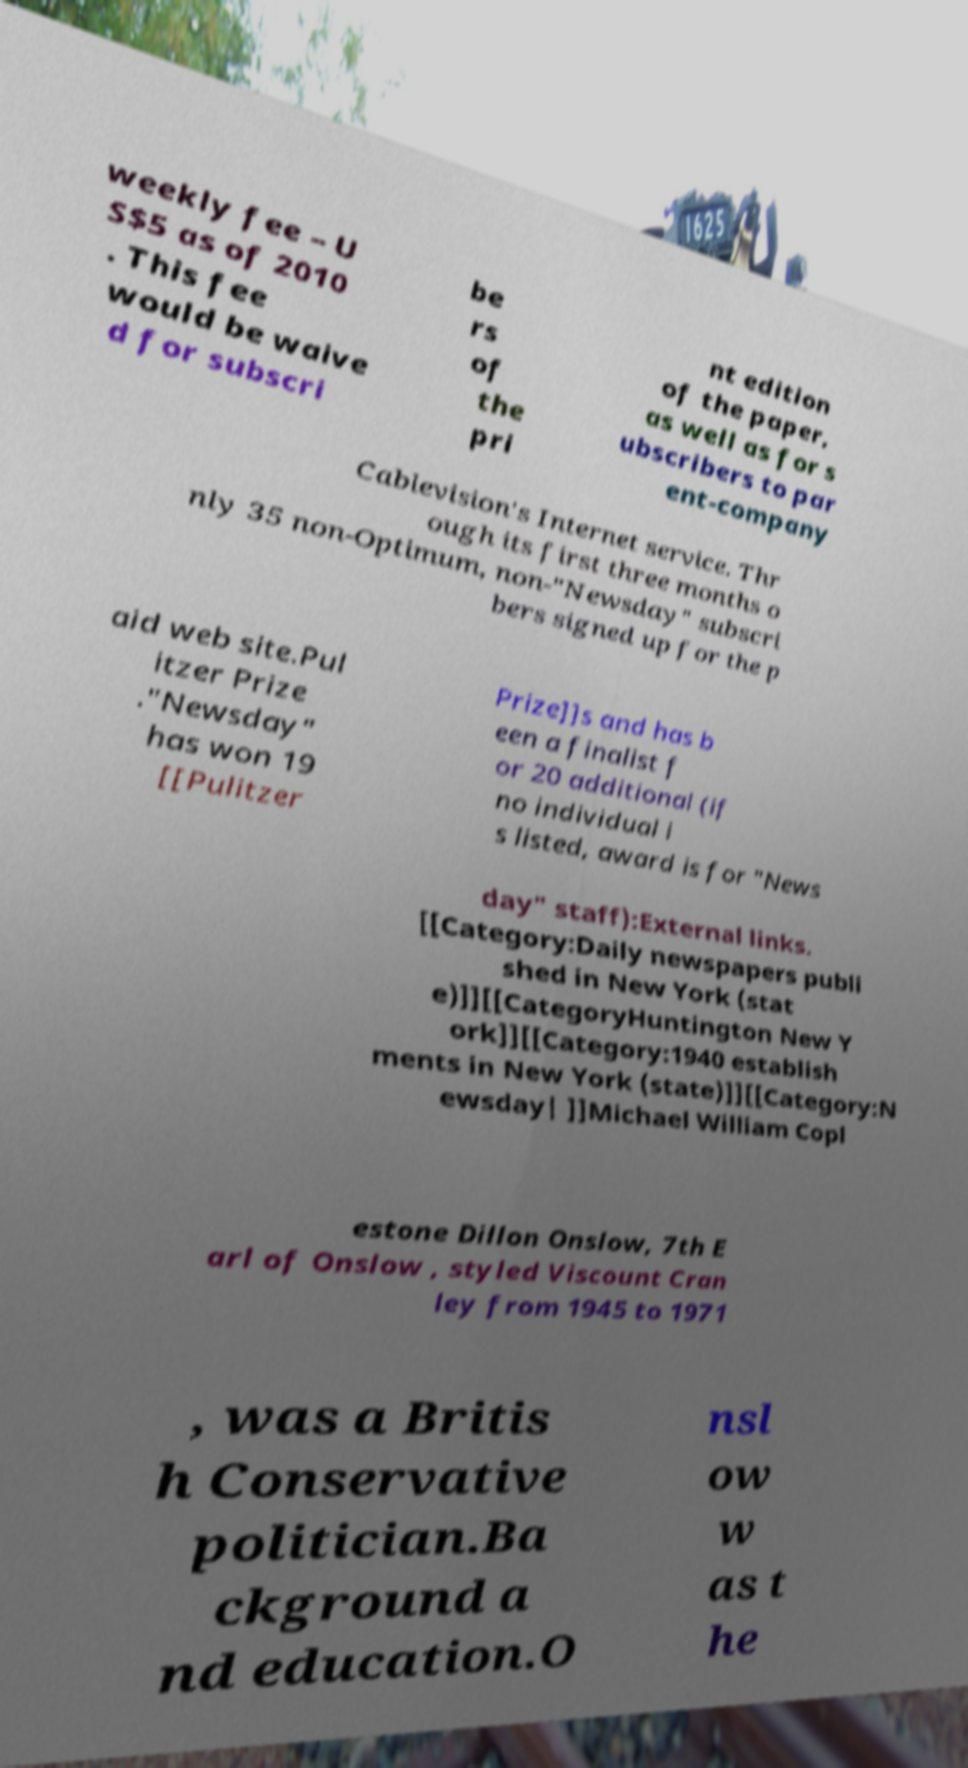What messages or text are displayed in this image? I need them in a readable, typed format. weekly fee – U S$5 as of 2010 . This fee would be waive d for subscri be rs of the pri nt edition of the paper, as well as for s ubscribers to par ent-company Cablevision's Internet service. Thr ough its first three months o nly 35 non-Optimum, non-"Newsday" subscri bers signed up for the p aid web site.Pul itzer Prize ."Newsday" has won 19 [[Pulitzer Prize]]s and has b een a finalist f or 20 additional (if no individual i s listed, award is for "News day" staff):External links. [[Category:Daily newspapers publi shed in New York (stat e)]][[CategoryHuntington New Y ork]][[Category:1940 establish ments in New York (state)]][[Category:N ewsday| ]]Michael William Copl estone Dillon Onslow, 7th E arl of Onslow , styled Viscount Cran ley from 1945 to 1971 , was a Britis h Conservative politician.Ba ckground a nd education.O nsl ow w as t he 